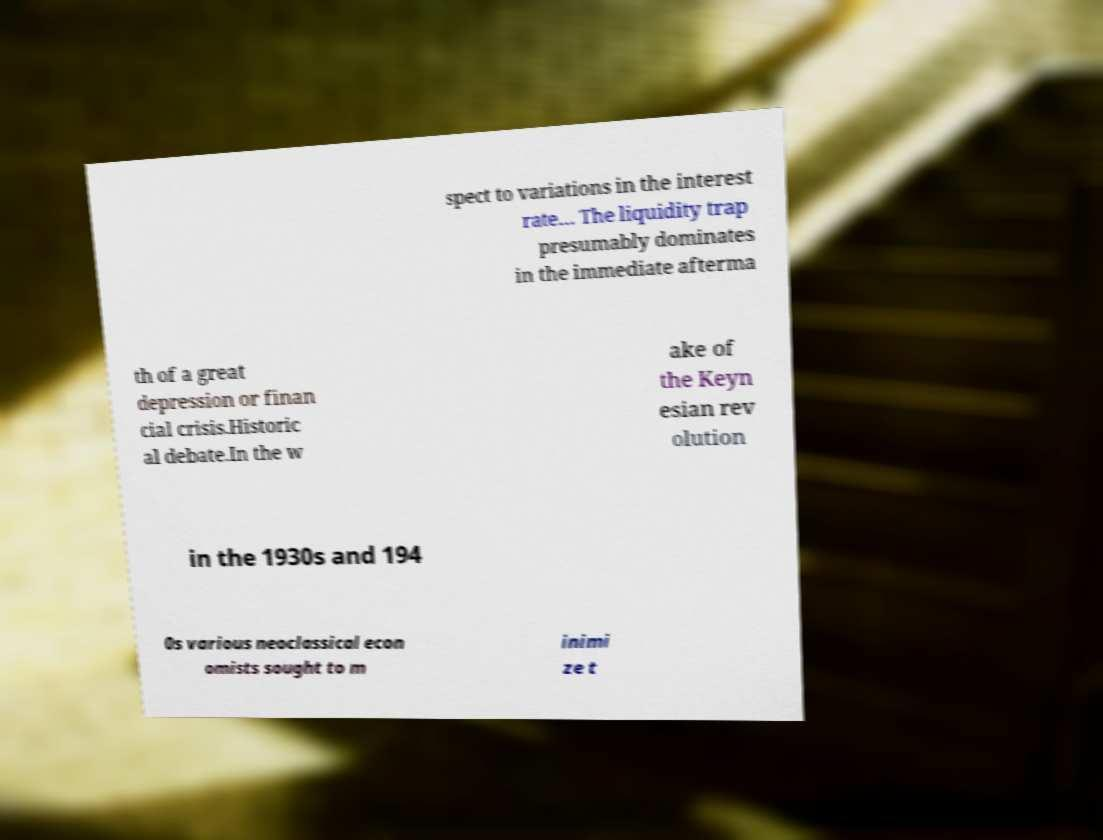I need the written content from this picture converted into text. Can you do that? spect to variations in the interest rate… The liquidity trap presumably dominates in the immediate afterma th of a great depression or finan cial crisis.Historic al debate.In the w ake of the Keyn esian rev olution in the 1930s and 194 0s various neoclassical econ omists sought to m inimi ze t 